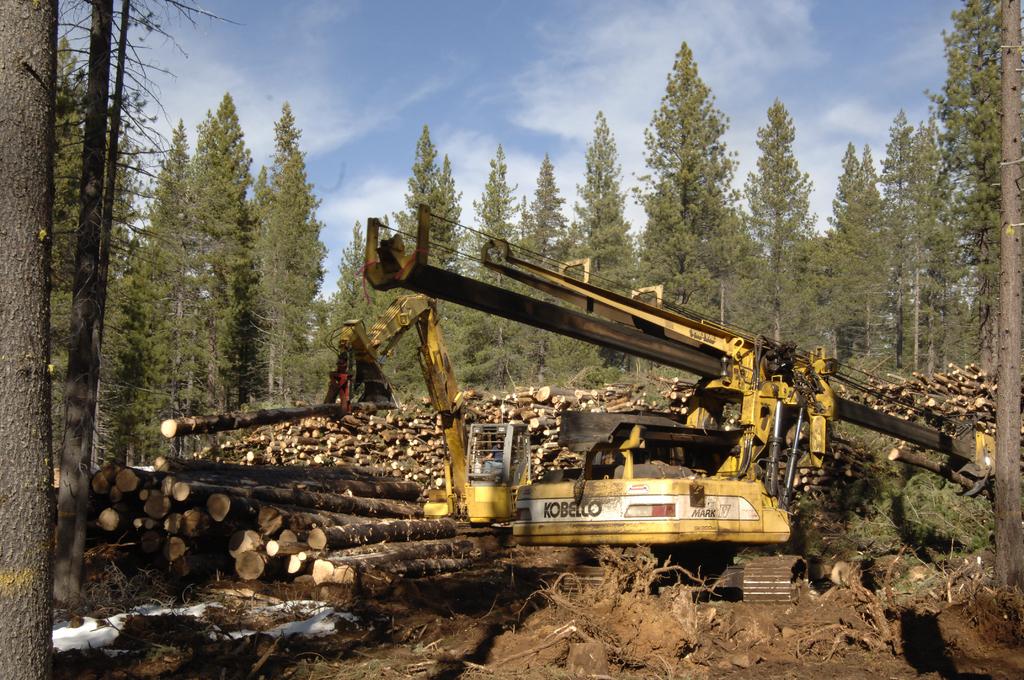What is the brand of the machine?
Your answer should be very brief. Kobello. 